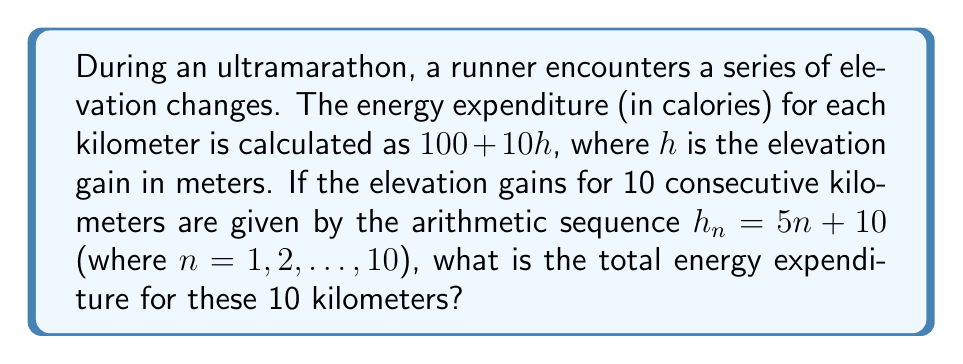Give your solution to this math problem. 1) First, let's find the elevation gain for each kilometer:
   $h_1 = 5(1) + 10 = 15$
   $h_2 = 5(2) + 10 = 20$
   ...
   $h_{10} = 5(10) + 10 = 60$

2) The energy expenditure for each kilometer is $100 + 10h_n$:
   $E_n = 100 + 10(5n + 10) = 100 + 50n + 100 = 200 + 50n$

3) We need to find the sum of this sequence for $n = 1$ to $10$:
   $$\sum_{n=1}^{10} (200 + 50n)$$

4) This can be split into two sums:
   $$10(200) + 50\sum_{n=1}^{10} n$$

5) We know that $\sum_{n=1}^{10} n = \frac{10(10+1)}{2} = 55$

6) Therefore, the total energy expenditure is:
   $$2000 + 50(55) = 2000 + 2750 = 4750$$
Answer: 4750 calories 